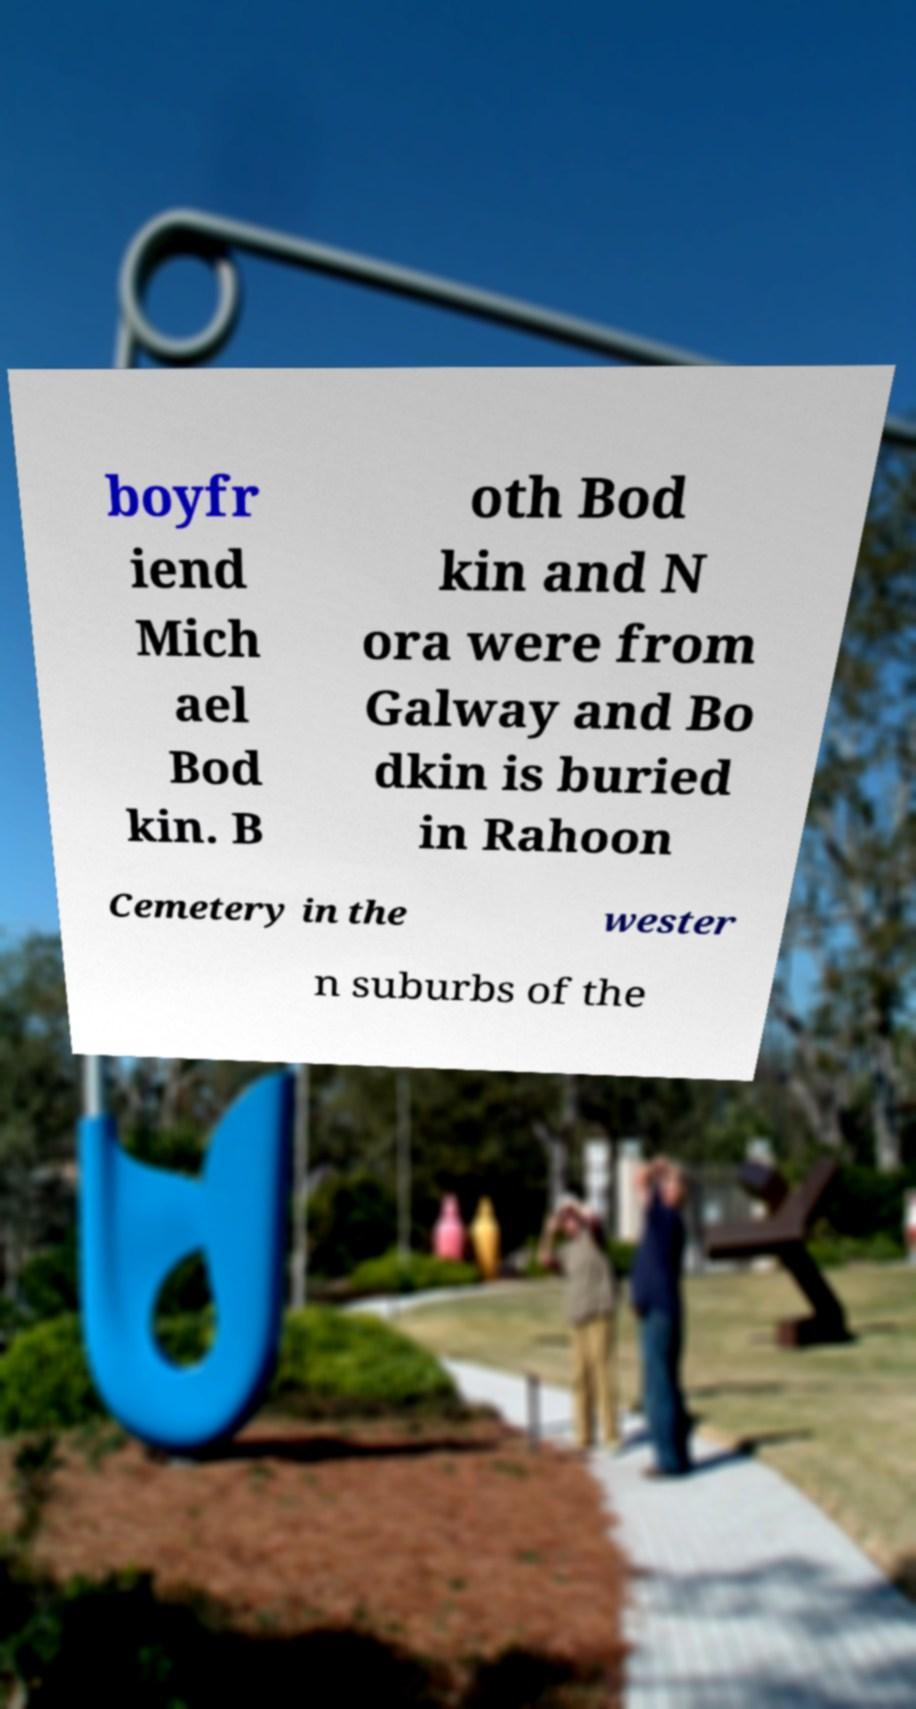Can you accurately transcribe the text from the provided image for me? boyfr iend Mich ael Bod kin. B oth Bod kin and N ora were from Galway and Bo dkin is buried in Rahoon Cemetery in the wester n suburbs of the 